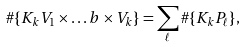<formula> <loc_0><loc_0><loc_500><loc_500>\# \{ K _ { k } V _ { 1 } \times \dots b \times V _ { k } \} = \sum _ { \ell } \# \{ K _ { k } P _ { \ell } \} ,</formula> 